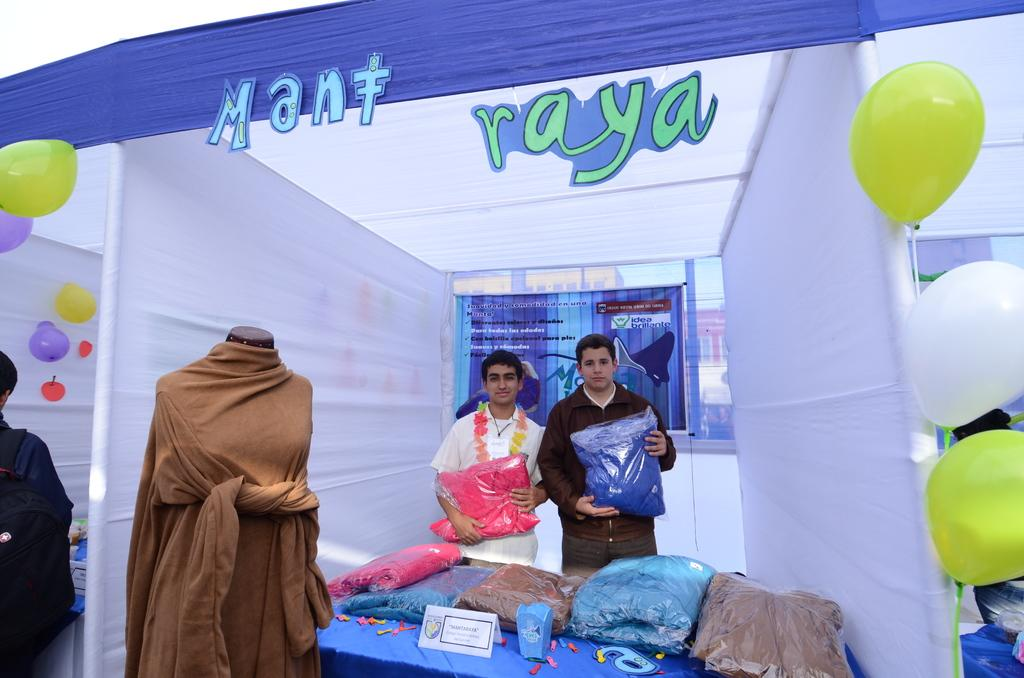Who or what is present in the image? There are people in the image. What else can be seen in the image besides the people? There are clothes, balloons, a board, and objects on a table in the image. Can you describe the board in the image? There is a board in the image, but its specific purpose or appearance cannot be determined from the provided facts. What might be the purpose of the objects on the table? The purpose of the objects on the table cannot be determined from the provided facts. What type of brass instrument is being played by the chicken in the image? There is no chicken or brass instrument present in the image. 